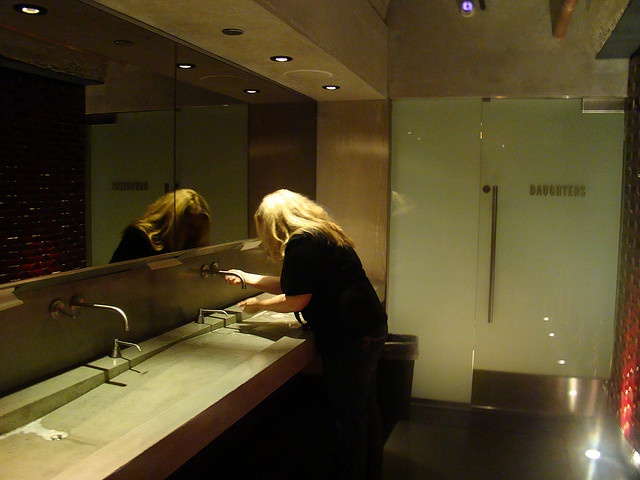Describe the objects in this image and their specific colors. I can see sink in black, tan, khaki, and olive tones and people in black, olive, maroon, and khaki tones in this image. 